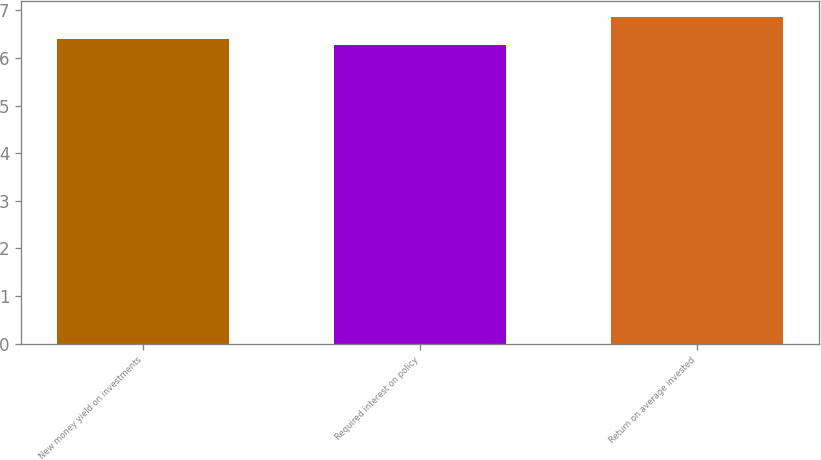Convert chart to OTSL. <chart><loc_0><loc_0><loc_500><loc_500><bar_chart><fcel>New money yield on investments<fcel>Required interest on policy<fcel>Return on average invested<nl><fcel>6.4<fcel>6.28<fcel>6.86<nl></chart> 